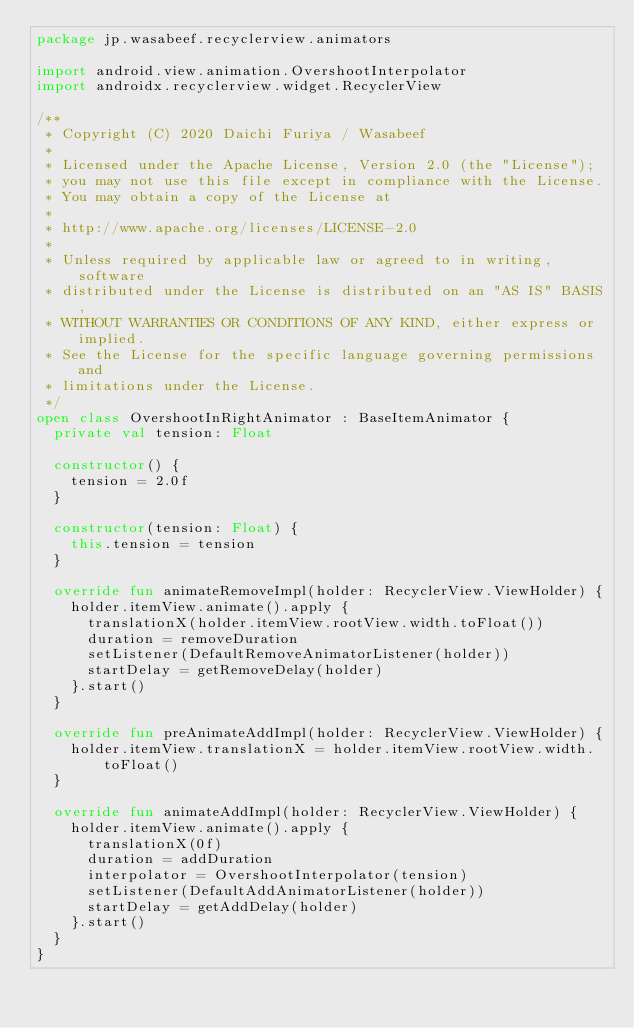Convert code to text. <code><loc_0><loc_0><loc_500><loc_500><_Kotlin_>package jp.wasabeef.recyclerview.animators

import android.view.animation.OvershootInterpolator
import androidx.recyclerview.widget.RecyclerView

/**
 * Copyright (C) 2020 Daichi Furiya / Wasabeef
 *
 * Licensed under the Apache License, Version 2.0 (the "License");
 * you may not use this file except in compliance with the License.
 * You may obtain a copy of the License at
 *
 * http://www.apache.org/licenses/LICENSE-2.0
 *
 * Unless required by applicable law or agreed to in writing, software
 * distributed under the License is distributed on an "AS IS" BASIS,
 * WITHOUT WARRANTIES OR CONDITIONS OF ANY KIND, either express or implied.
 * See the License for the specific language governing permissions and
 * limitations under the License.
 */
open class OvershootInRightAnimator : BaseItemAnimator {
  private val tension: Float

  constructor() {
    tension = 2.0f
  }

  constructor(tension: Float) {
    this.tension = tension
  }

  override fun animateRemoveImpl(holder: RecyclerView.ViewHolder) {
    holder.itemView.animate().apply {
      translationX(holder.itemView.rootView.width.toFloat())
      duration = removeDuration
      setListener(DefaultRemoveAnimatorListener(holder))
      startDelay = getRemoveDelay(holder)
    }.start()
  }

  override fun preAnimateAddImpl(holder: RecyclerView.ViewHolder) {
    holder.itemView.translationX = holder.itemView.rootView.width.toFloat()
  }

  override fun animateAddImpl(holder: RecyclerView.ViewHolder) {
    holder.itemView.animate().apply {
      translationX(0f)
      duration = addDuration
      interpolator = OvershootInterpolator(tension)
      setListener(DefaultAddAnimatorListener(holder))
      startDelay = getAddDelay(holder)
    }.start()
  }
}
</code> 